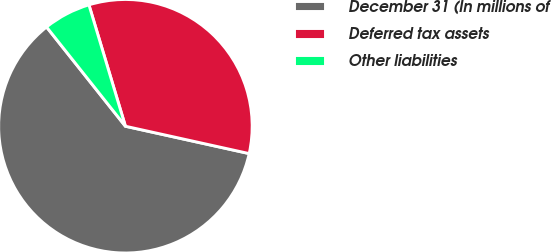Convert chart. <chart><loc_0><loc_0><loc_500><loc_500><pie_chart><fcel>December 31 (In millions of<fcel>Deferred tax assets<fcel>Other liabilities<nl><fcel>60.85%<fcel>33.11%<fcel>6.04%<nl></chart> 